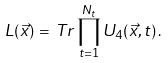<formula> <loc_0><loc_0><loc_500><loc_500>L ( \vec { x } ) \, = \, T r \prod _ { t = 1 } ^ { N _ { t } } U _ { 4 } ( \vec { x } , t ) \, .</formula> 